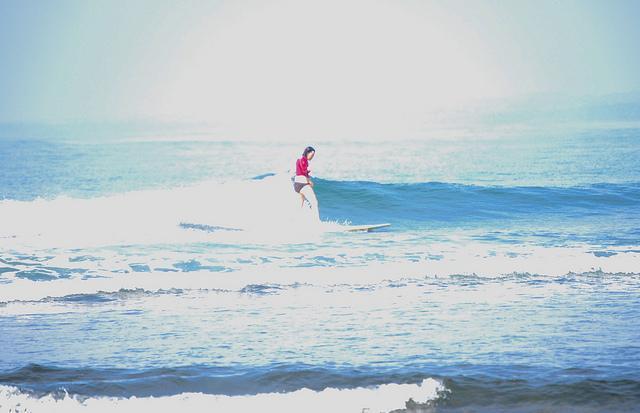How many people are in the water?
Give a very brief answer. 1. 